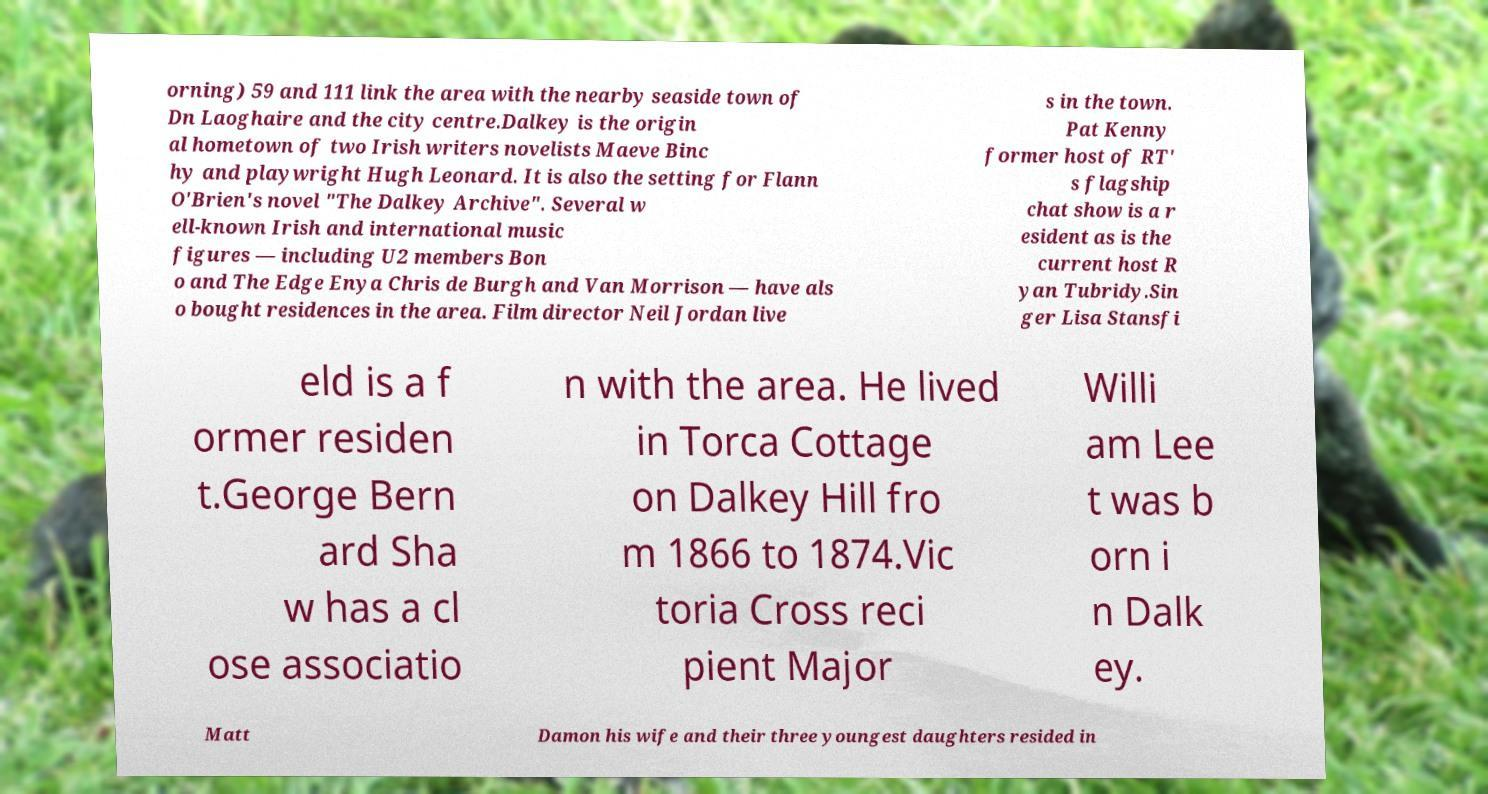Please identify and transcribe the text found in this image. orning) 59 and 111 link the area with the nearby seaside town of Dn Laoghaire and the city centre.Dalkey is the origin al hometown of two Irish writers novelists Maeve Binc hy and playwright Hugh Leonard. It is also the setting for Flann O'Brien's novel "The Dalkey Archive". Several w ell-known Irish and international music figures — including U2 members Bon o and The Edge Enya Chris de Burgh and Van Morrison — have als o bought residences in the area. Film director Neil Jordan live s in the town. Pat Kenny former host of RT' s flagship chat show is a r esident as is the current host R yan Tubridy.Sin ger Lisa Stansfi eld is a f ormer residen t.George Bern ard Sha w has a cl ose associatio n with the area. He lived in Torca Cottage on Dalkey Hill fro m 1866 to 1874.Vic toria Cross reci pient Major Willi am Lee t was b orn i n Dalk ey. Matt Damon his wife and their three youngest daughters resided in 